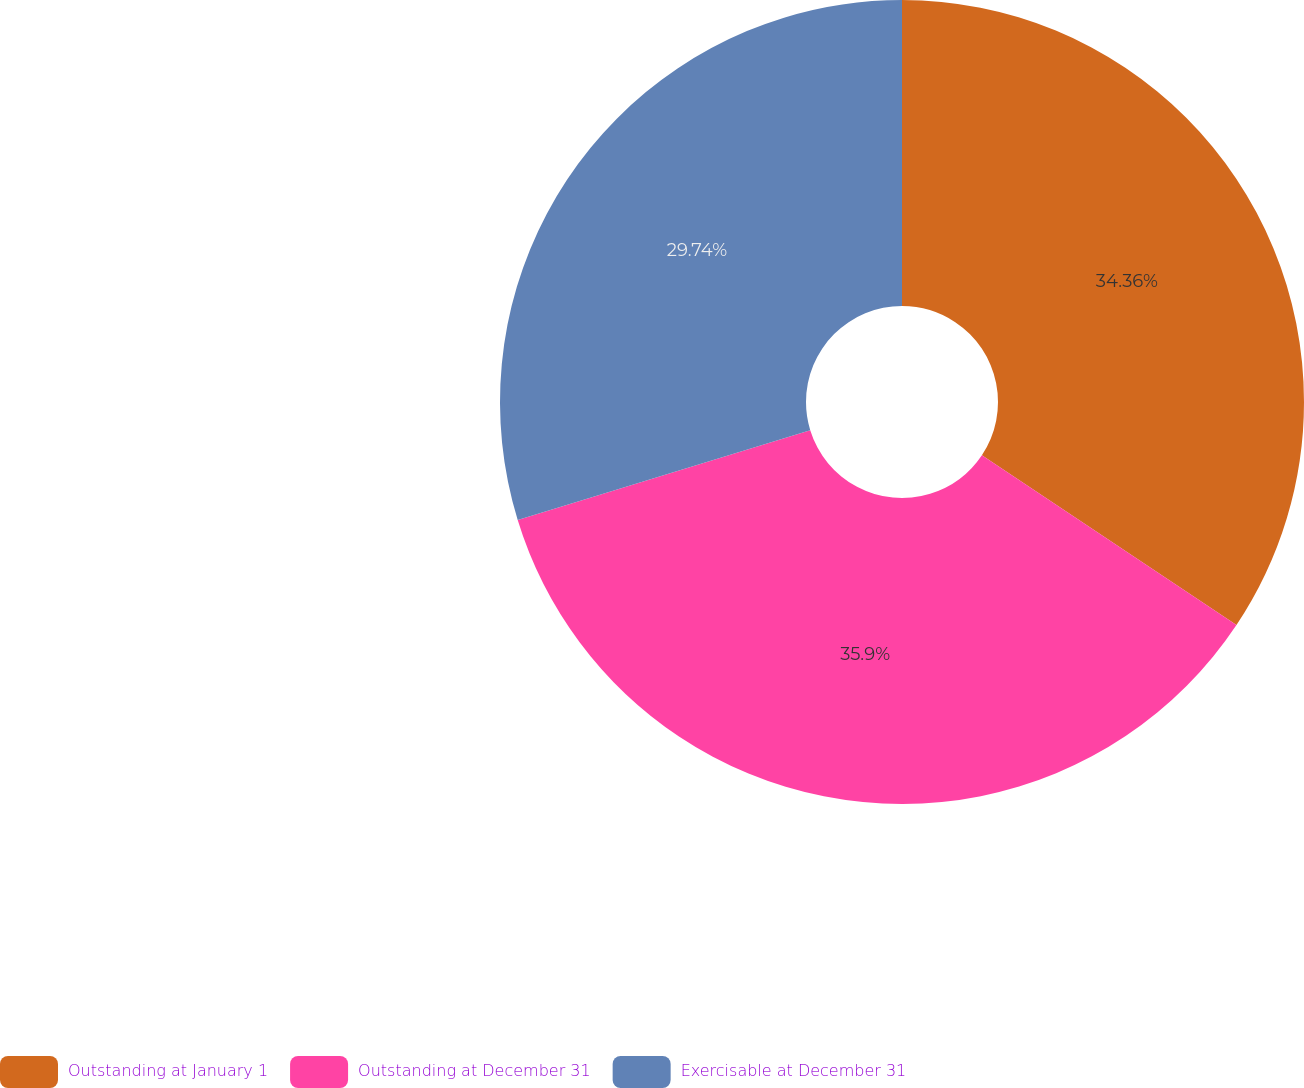Convert chart to OTSL. <chart><loc_0><loc_0><loc_500><loc_500><pie_chart><fcel>Outstanding at January 1<fcel>Outstanding at December 31<fcel>Exercisable at December 31<nl><fcel>34.36%<fcel>35.9%<fcel>29.74%<nl></chart> 